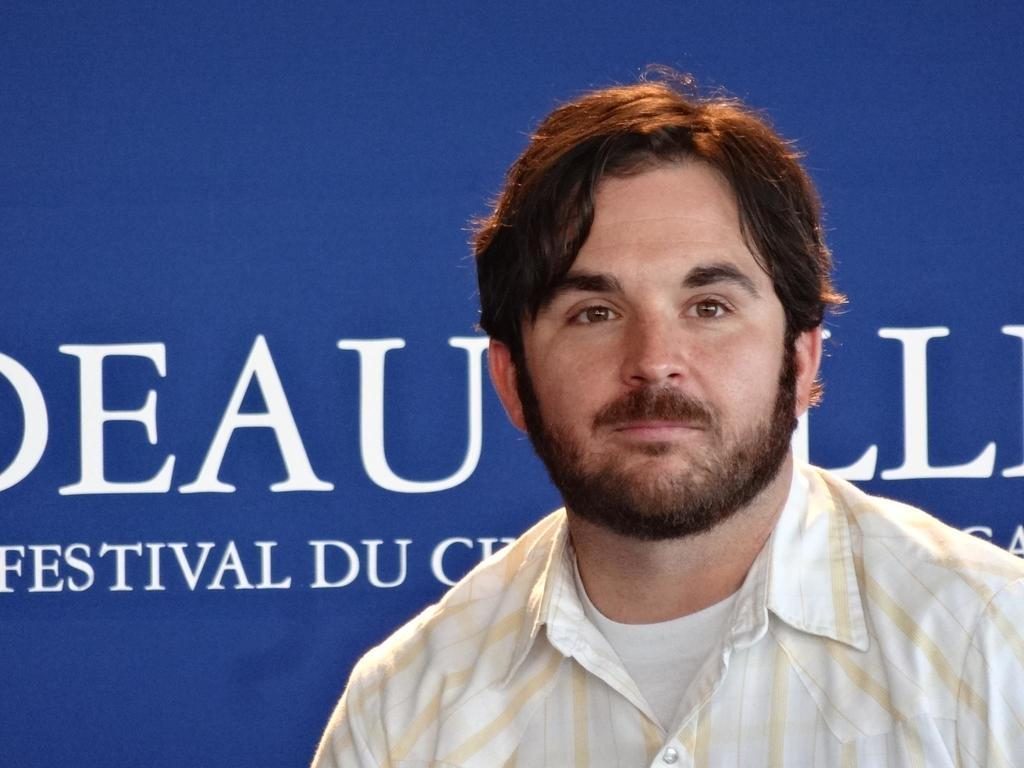What is located in the foreground of the image? There is a person in the foreground of the image. What can be seen in the background of the image? There is a board in the background of the image. What is written or displayed on the board? There is text on the board. Can you see any sea creatures swimming near the person in the image? There is no sea or sea creatures present in the image. Is the person wearing a scarf in the image? The provided facts do not mention anything about the person's clothing, so we cannot determine if they are wearing a scarf. 